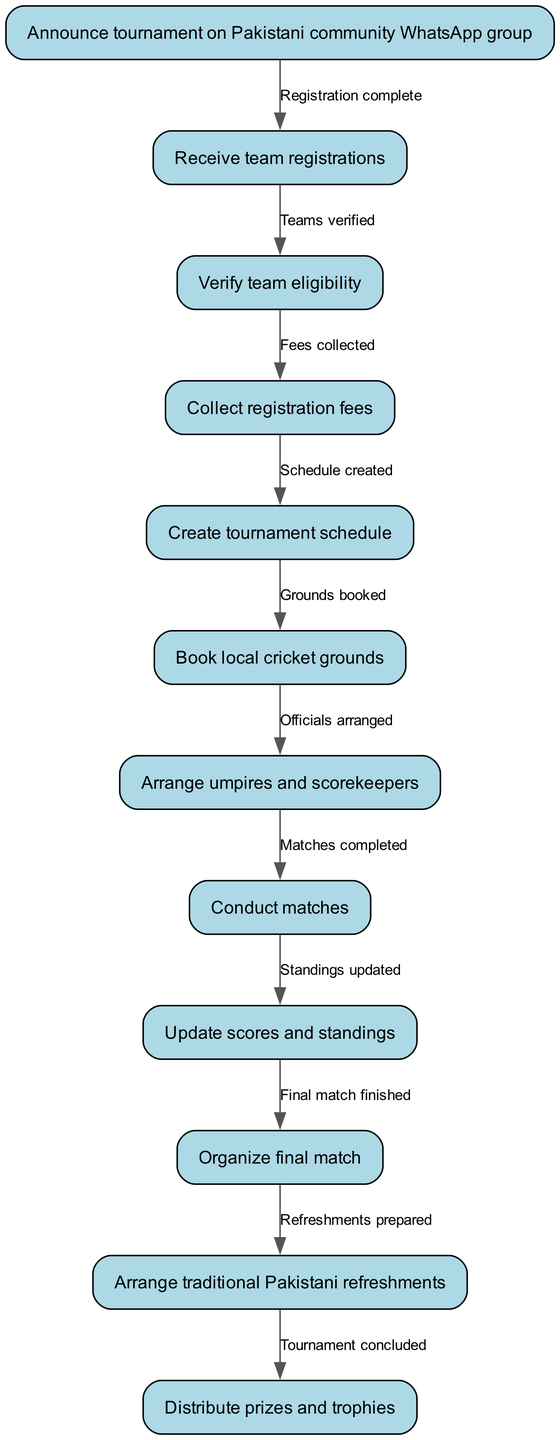What is the first step in organizing the tournament? The first step is announcing the tournament on the Pakistani community WhatsApp group. This is identified as the initial node in the diagram.
Answer: Announce tournament on Pakistani community WhatsApp group How many nodes are in the diagram? The diagram contains a total of 12 nodes. This is determined by counting each unique step listed in the 'nodes' section of the data.
Answer: 12 What action follows verifying team eligibility? After verifying team eligibility, the next action is to collect registration fees, which is the subsequent node in the flow.
Answer: Collect registration fees What is the last step in the tournament process? The final step in the tournament process is distributing prizes and trophies. This is indicated as the last node in the activity diagram.
Answer: Distribute prizes and trophies How many edges connect the nodes? There are 11 edges connecting the nodes, as each connection signifies a transition from one step to the next within the flow of the tournament organization.
Answer: 11 What must be done before arranging umpires and scorekeepers? Before arranging umpires and scorekeepers, it is necessary to book local cricket grounds. This is indicated as a prerequisite in the sequence of actions.
Answer: Book local cricket grounds What step occurs after conducting matches? After conducting matches, the next step is to update scores and standings. This follows directly in the sequential flow of the activities.
Answer: Update scores and standings What step directly precedes the final match? The step that directly precedes the final match is organizing the final match itself. It indicates a clear progression towards concluding the tournament.
Answer: Organize final match What action is related to preparing food? The action related to preparing food is arranging traditional Pakistani refreshments, which occurs before the prize distribution.
Answer: Arrange traditional Pakistani refreshments 